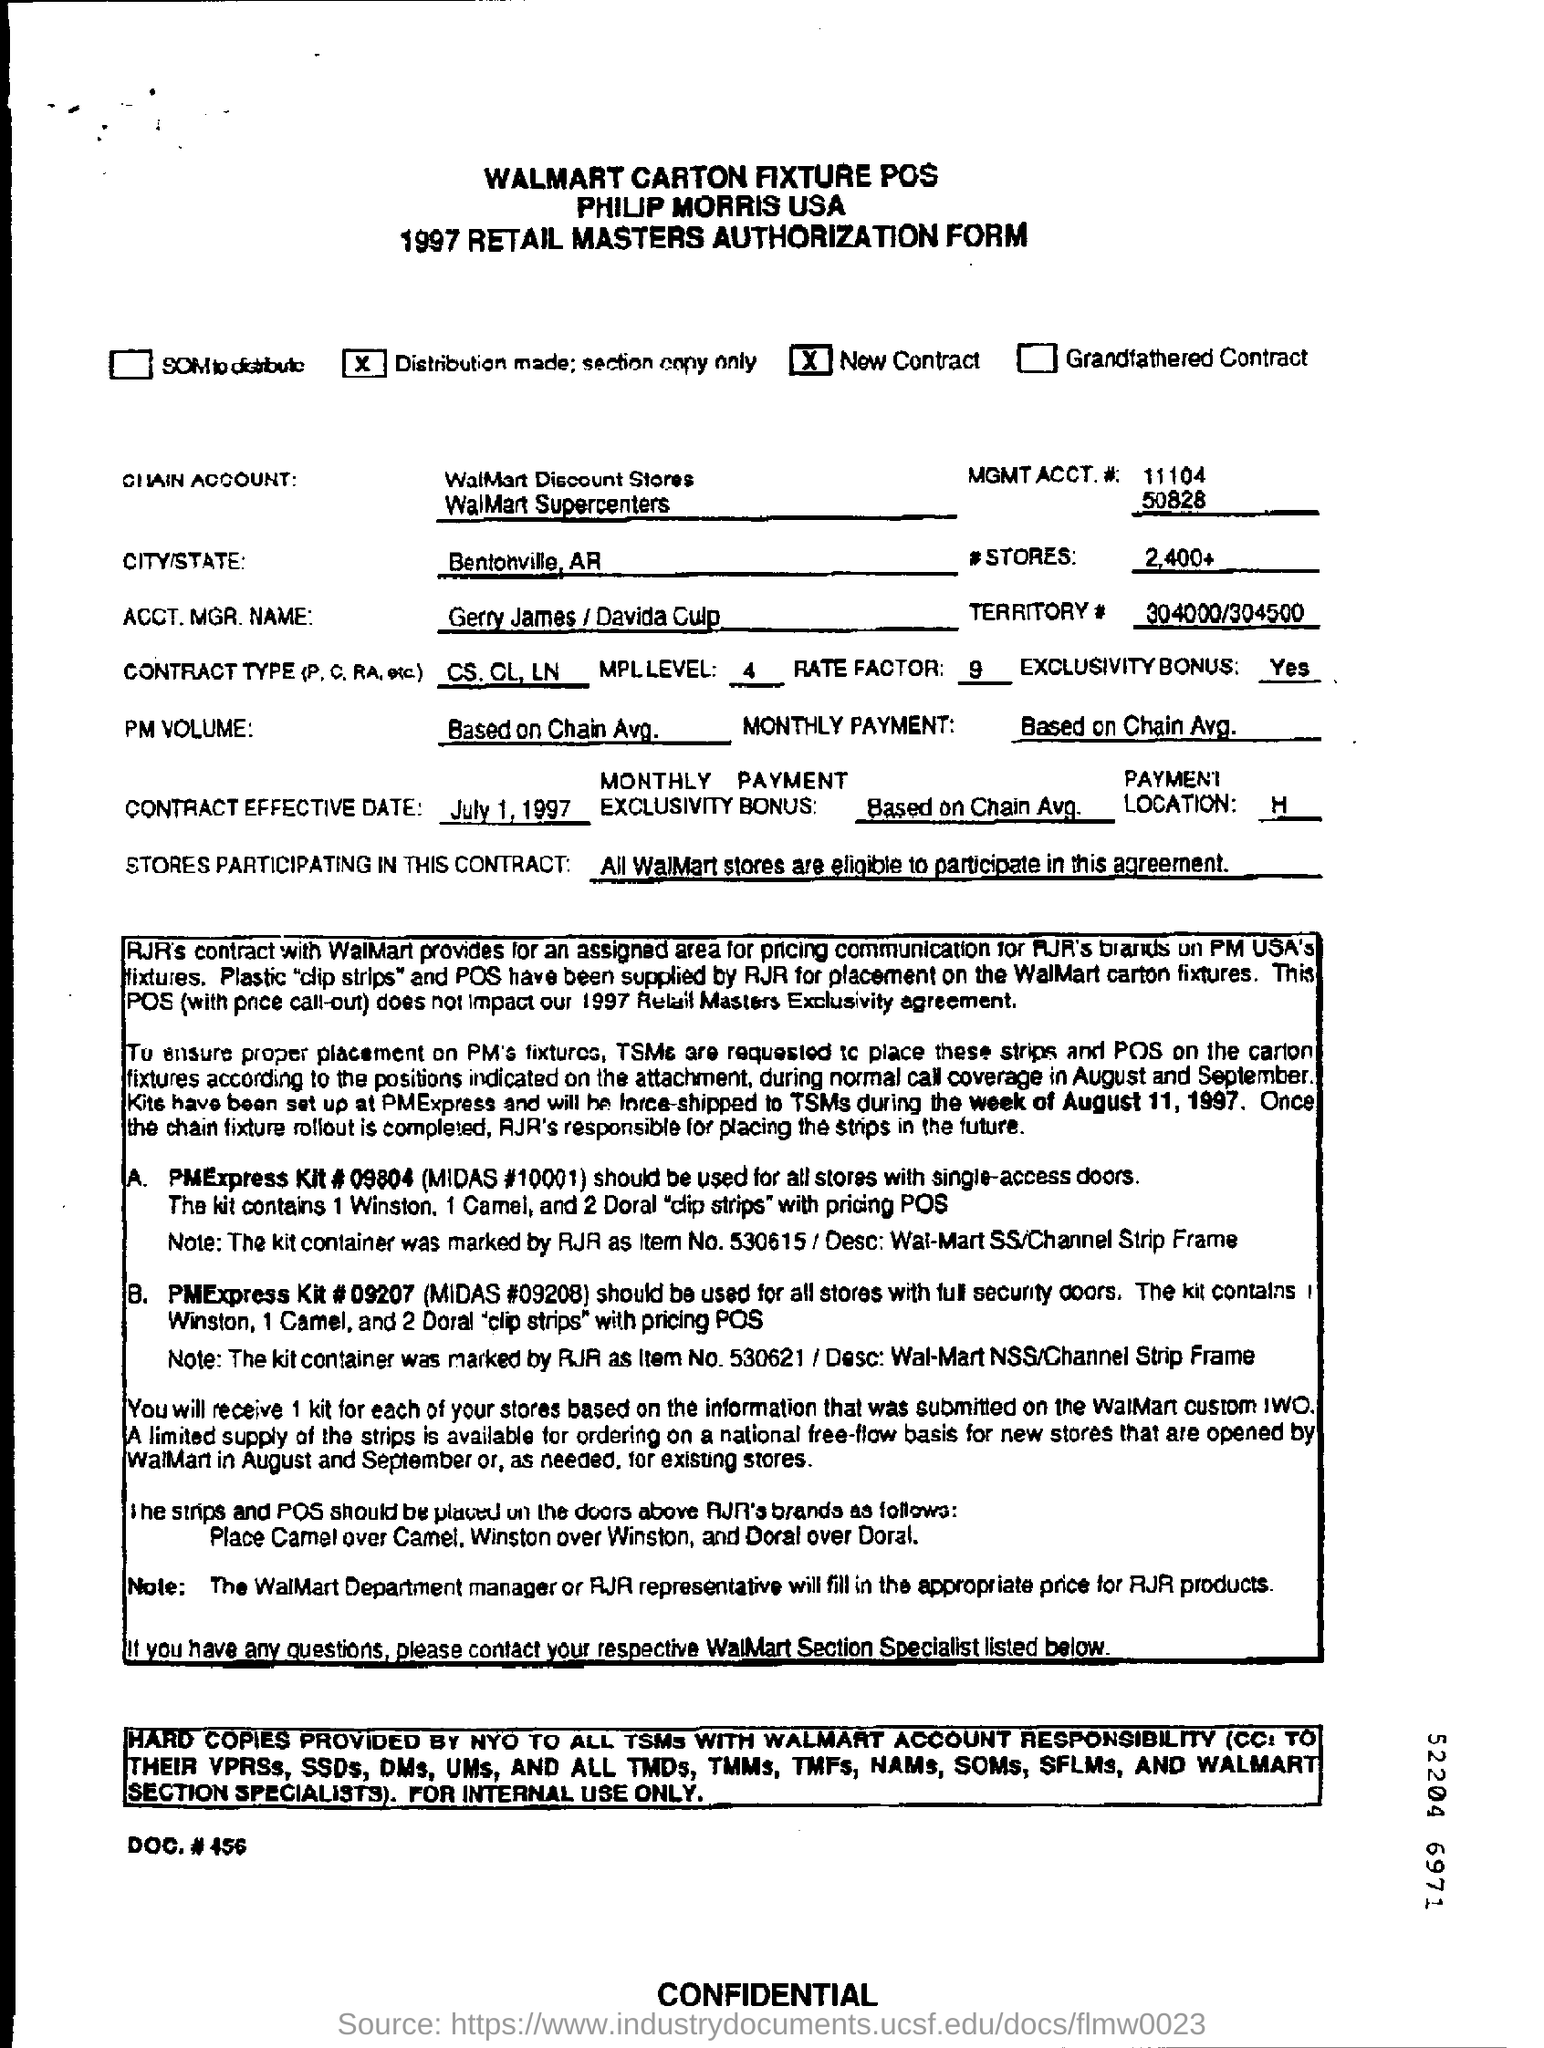Give some essential details in this illustration. What is the projected volume of PM based on the average from the blockchain? The contract type, which includes p, c, RA, etc., is CS.CL and LN. The name of the Walmart Supercenter chain account is Walmart Supercenters. The MGMT ACCT.# 11104 and 50828 are mentioned. It is mentioned in the territory that 304000/304500 has been completed. 